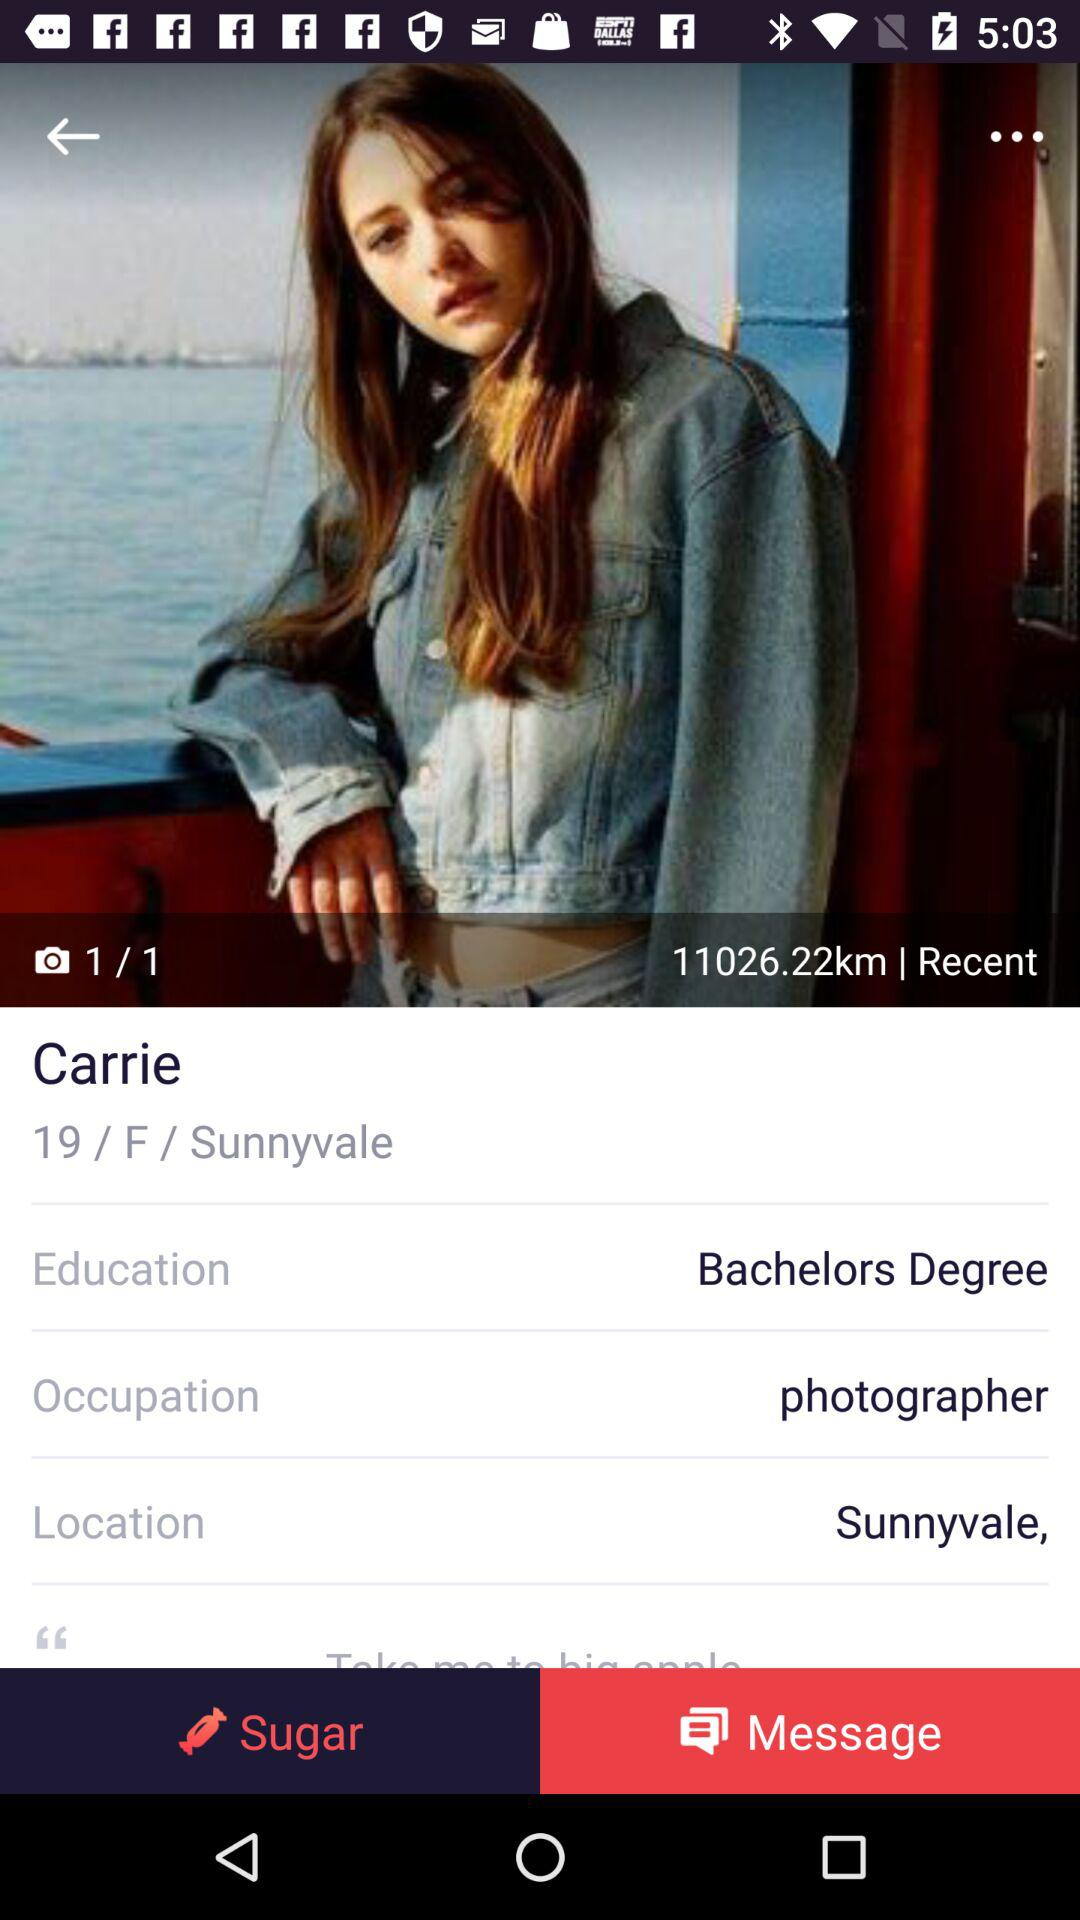What is the age of the girl? The girl is 19 years old. 